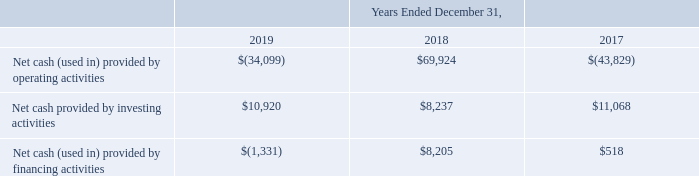Liquidity and Capital Resources
Our cash, cash equivalents, and short-term investments consist primarily of money market funds and U.S. treasury bills. All of our short-term investments are classified as available-for-sale. The securities are stated at market value, with unrealized gains and losses reported as a component of accumulated other comprehensive income, within stockholders’ equity. As of December 31, 2019, our cash, cash equivalents, and short-term investments totaled $89.5 million, a decrease of $35.4 million from $124.9 million on December 31, 2018.
A summary of select cash flow information for the years ended December 31, 2019, 2018 and 2017 (in thousands):
2019 Compared to 2018
Cash provided by (used in) operating activities - Net cash used in operating activities was $34.1 million during 2019 compared to $69.9 million cash provided by operating activities during 2018, primarily due to a $74.4 million decrease in net income, a $25.6 million decrease in deferred revenue, a $4.2 million increase in other assets, a $2.1 million increase in accounts and other receivables and a $0.9 million decrease in accrued compensation partially offset by a $3.8 million increase in other long-term liabilities. The decrease in deferred revenue primarily reflects the effect of the adoption of ASC 606 on January 1, 2018. Cash used in operating activities was also affected by a $0.5 million decrease in non-cash charges primarily related to a $3.2 million decrease in stock-based compensation expense, partially offset by a $0.9 million impairment charge related to the SJ Facility right-of-use lease asset and a $1.3 million increase in depreciation and amortization expense. The increase in depreciation and amortization expense is due primarily to amortization of right-of-use lease assets and the shortened useful life of the SJ Facility leasehold improvements and a $0.3 million increase in deferred income taxes.
Cash provided by investing activities - Net cash provided by investing activities during 2019 was $10.9 million, a decrease of $2.7 million compared to $8.2 million cash provided by investing activities during 2018. Net cash provided by investing activities during 2019 consisted of maturities of short-term investments of $20.0 million. This was partially offset by purchases of short-term investments of $8.9 million and purchases of property, plant and equipment of $0.2 million. Net cash provided by investing activities during 2018 consisted of maturities of short-term investments of $26.0 million. This was partially offset by purchases of short-term investments of $17.7 million and purchases of property, plant, and equipment of $0.1 million.
Cash provided by financing activities — Net cash provided by financing activities during 2019 was $1.3 million, a decrease of $9.5 million compared to $8.2 million cash provided by financing activities during 2018. Net cash used in financing activities during 2019 consisted of $2.7 million used to purchase of treasury stock partially offset by $1.4 million in cash proceeds from stock option exercises and stock purchases under our employee stock purchase plan. Net cash provided by financing activities during 2018 consisted primarily of $8.2 million in proceeds from stock option exercises and stock purchases under our employee stock purchase plan.
2018 Compared to 2017
Cash provided by (used in) operating activities - Net cash provided by operating activities was $69.9 million during 2018 compared to $43.8 million cash used in operating activities during 2017. The $113.8 million change was primarily driven by $99.6 million increase in net income (loss), from $45.3 million net loss for 2017 to $54.3 million net income for 2018 and $27.0 million increase in deferred revenue, partially offset by $7.0 million increase in other assets, $4.2 million increase in prepaid expenses and other current assets, and $3.7 million decrease in accounts payable. The increases in deferred revenue and other non-current assets primarily reflected the effect of the adoption of ASC 606 on January 1, 2018. Cash provided by operating activities was also affected by an increase in non-cash charges of $2.6 million primarily related to higher stock-based compensation expense incurred for 2018 compared to 2017.
Cash provided by (used in) investing activities - Net cash provided by investing activities during 2018 was $8.2 million, a decrease of $2.8 million compared to $11.1 million cash provided by investing activities during 2017. Net cash provided by investing activities during 2018 consisted of maturities of short-term investments of $26.0 million partially offset by purchases of short-term investments of $17.7 million and purchases of property, plant and equipment of $0.1 million. Net cash provided by investing activities during 2017 consisted of maturities of short-term investments of $35.0 million partially offset by purchases of short-term investments of $23.8 million and purchases of property, plant, and equipment of $0.1 million.
Cash provided by (used in) financing activities - Net cash provided by financing activities during 2018 was $8.2 million an increase of $7.7 million compared to $0.5 million net cash provided by financing activities during 2017. Net cash provided by financing activities during 2018 consisted primarily of $8.2 million in proceeds from stock option exercises and stock purchases under our employee stock purchase plan. Net cash provided by financing activities during 2017 consisted primarily of $0.8 million proceeds from stock option exercises and stock purchases under our employee stock purchase plan partially offset by repurchases of treasury stock of $0.3 million.
We believe that our cash, cash equivalents, and short-term investments will be sufficient to meet our working capital needs for at least the next twelve months. Of our total cash, cash equivalents, and short-term investments of $89.5 million as of December 31, 2019, 5% was held by our foreign subsidiaries and subject to repatriation tax effects. Our intent is to permanently reinvest all of our earnings from foreign operations, and current plans do not anticipate that we will need funds generated from foreign operations to fund our domestic operations. We will continue to invest in, protect, and defend our extensive IP portfolio, which is expected to result in the continued use of cash. At December 31, 2019 there was $30.6 million remaining under our previously-approved share repurchase program. We anticipate that capital expenditures for property and equipment for the year ending December 31, 2020 will be less than $1.0 million. Cash from operations could also be affected by various risks and uncertainties, including, but not limited to the risks detailed in Part I, Item 1A, Risk Factors of this Annual Report on Form 10-K.
What was the cash, cash equivalents and short-term investments in 2019 and 2018? $89.5 million, $124.9 million. What affected the decrease in deferred revenue? The effect of the adoption of asc 606 on january 1, 2018. What was the Net cash (used in) provided by operating activities in 2019?
Answer scale should be: thousand. $(34,099). In which year was Net cash provided by investing activities less than 10,000 thousands? Locate and analyze net cash provided by investing activities in row 4
answer: 2018. What was the change in the Net cash (used in) provided by operating activities from 2018 to 2019?
Answer scale should be: thousand. -34,099 - 69,924
Answer: -104023. What was the average Net cash provided by investing activities from 2017-2019?
Answer scale should be: thousand. (10,920 + 8,237 + 11,068) / 3
Answer: 10075. 